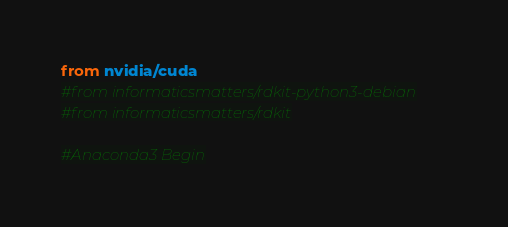Convert code to text. <code><loc_0><loc_0><loc_500><loc_500><_Dockerfile_>from nvidia/cuda
#from informaticsmatters/rdkit-python3-debian
#from informaticsmatters/rdkit

#Anaconda3 Begin</code> 